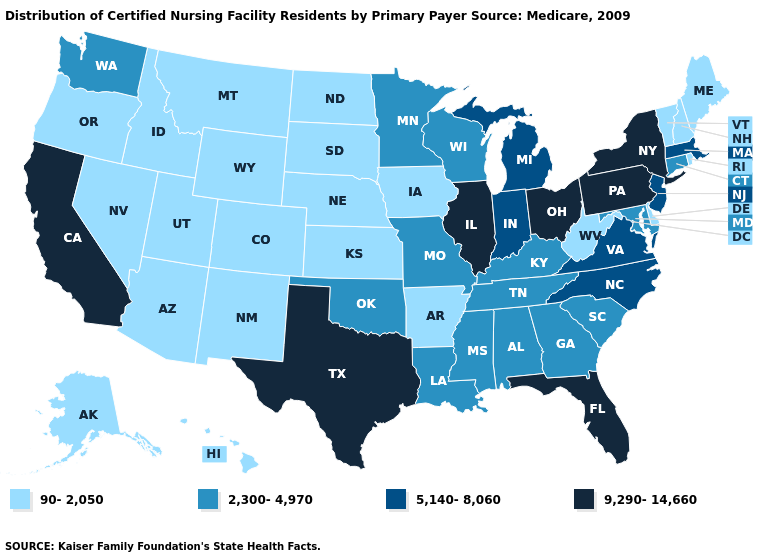What is the value of Oklahoma?
Concise answer only. 2,300-4,970. Does California have the highest value in the West?
Be succinct. Yes. Does Minnesota have a higher value than Arizona?
Quick response, please. Yes. What is the value of Montana?
Give a very brief answer. 90-2,050. Among the states that border Vermont , does New Hampshire have the highest value?
Give a very brief answer. No. What is the value of Arkansas?
Short answer required. 90-2,050. What is the value of Connecticut?
Quick response, please. 2,300-4,970. Name the states that have a value in the range 9,290-14,660?
Quick response, please. California, Florida, Illinois, New York, Ohio, Pennsylvania, Texas. Name the states that have a value in the range 2,300-4,970?
Keep it brief. Alabama, Connecticut, Georgia, Kentucky, Louisiana, Maryland, Minnesota, Mississippi, Missouri, Oklahoma, South Carolina, Tennessee, Washington, Wisconsin. What is the lowest value in the MidWest?
Short answer required. 90-2,050. Name the states that have a value in the range 9,290-14,660?
Write a very short answer. California, Florida, Illinois, New York, Ohio, Pennsylvania, Texas. Does New Hampshire have the same value as Nebraska?
Keep it brief. Yes. Name the states that have a value in the range 90-2,050?
Answer briefly. Alaska, Arizona, Arkansas, Colorado, Delaware, Hawaii, Idaho, Iowa, Kansas, Maine, Montana, Nebraska, Nevada, New Hampshire, New Mexico, North Dakota, Oregon, Rhode Island, South Dakota, Utah, Vermont, West Virginia, Wyoming. Which states hav the highest value in the MidWest?
Give a very brief answer. Illinois, Ohio. 